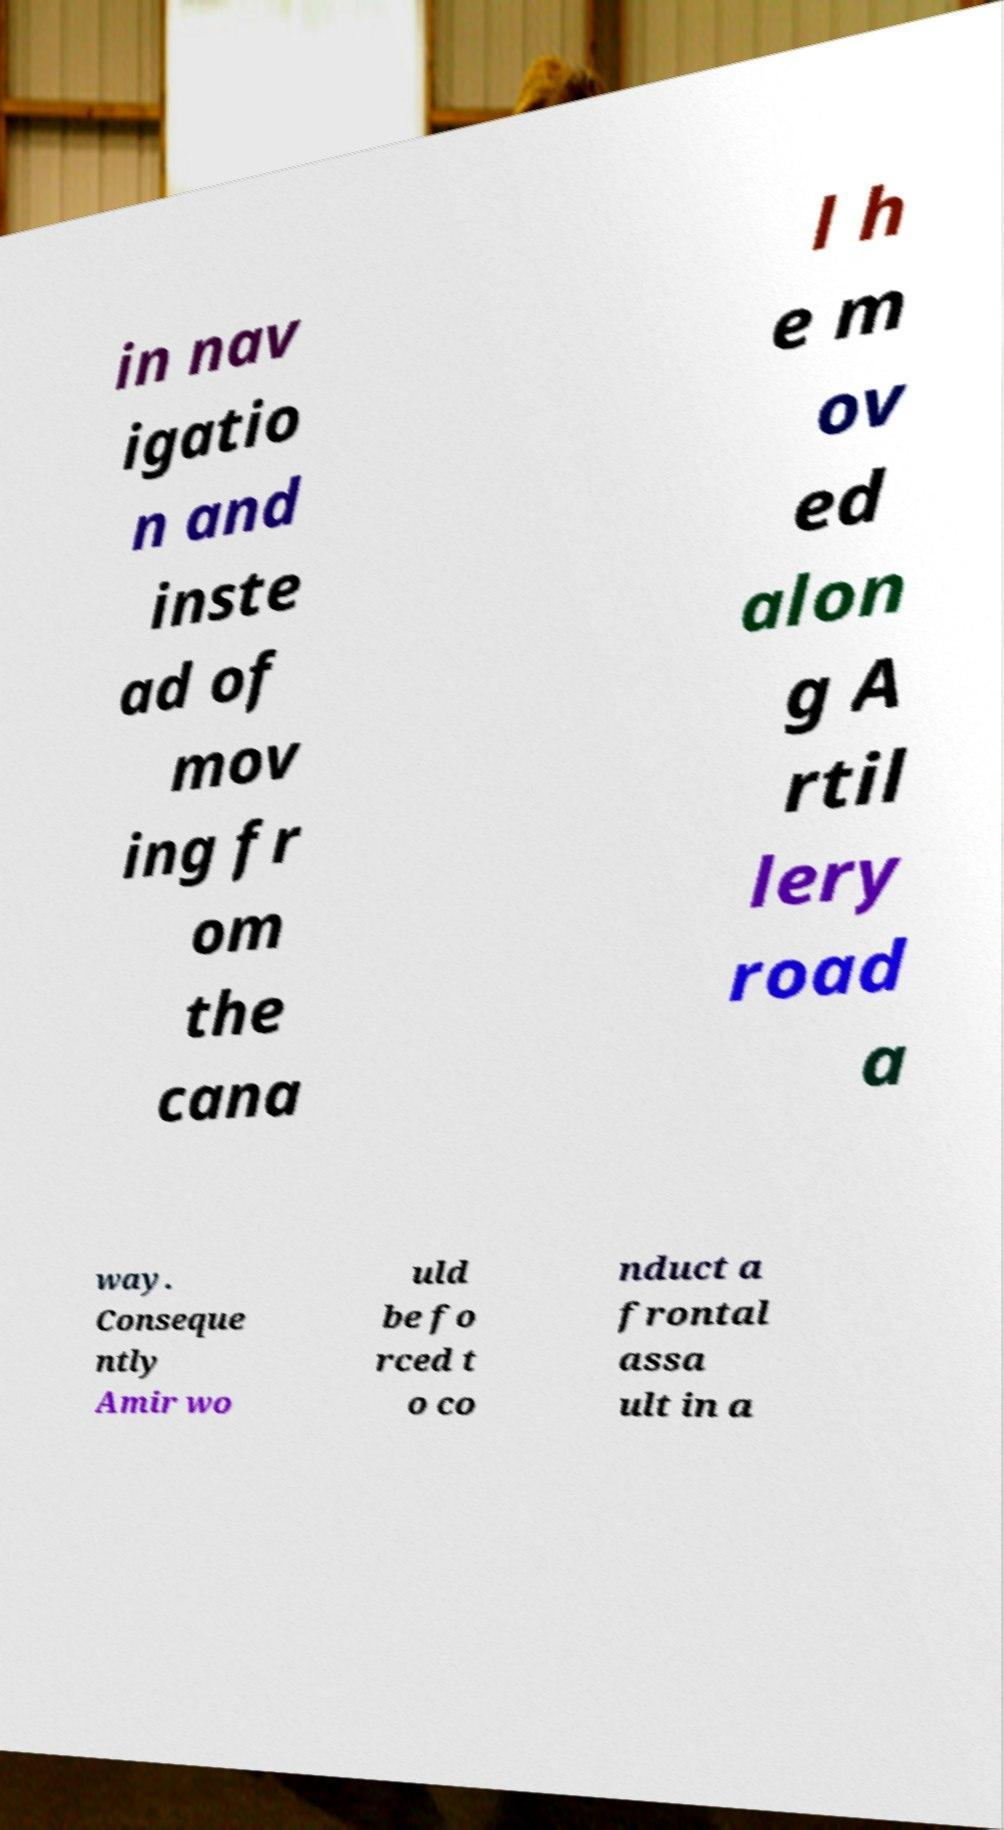What messages or text are displayed in this image? I need them in a readable, typed format. in nav igatio n and inste ad of mov ing fr om the cana l h e m ov ed alon g A rtil lery road a way. Conseque ntly Amir wo uld be fo rced t o co nduct a frontal assa ult in a 